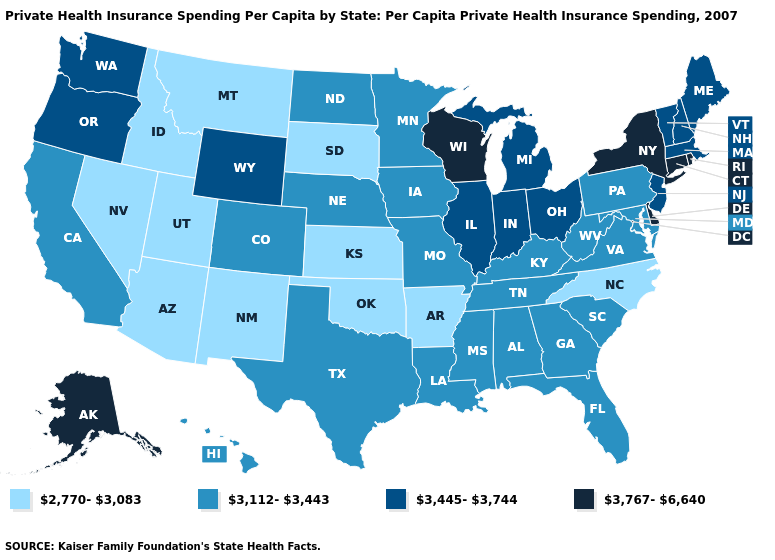Does the first symbol in the legend represent the smallest category?
Answer briefly. Yes. What is the highest value in the South ?
Give a very brief answer. 3,767-6,640. Which states hav the highest value in the Northeast?
Concise answer only. Connecticut, New York, Rhode Island. Does the map have missing data?
Answer briefly. No. Name the states that have a value in the range 3,445-3,744?
Write a very short answer. Illinois, Indiana, Maine, Massachusetts, Michigan, New Hampshire, New Jersey, Ohio, Oregon, Vermont, Washington, Wyoming. Is the legend a continuous bar?
Answer briefly. No. Name the states that have a value in the range 3,445-3,744?
Concise answer only. Illinois, Indiana, Maine, Massachusetts, Michigan, New Hampshire, New Jersey, Ohio, Oregon, Vermont, Washington, Wyoming. Name the states that have a value in the range 3,112-3,443?
Quick response, please. Alabama, California, Colorado, Florida, Georgia, Hawaii, Iowa, Kentucky, Louisiana, Maryland, Minnesota, Mississippi, Missouri, Nebraska, North Dakota, Pennsylvania, South Carolina, Tennessee, Texas, Virginia, West Virginia. Does Maryland have the highest value in the USA?
Write a very short answer. No. What is the value of Montana?
Write a very short answer. 2,770-3,083. Which states have the lowest value in the MidWest?
Concise answer only. Kansas, South Dakota. Among the states that border Maine , which have the lowest value?
Answer briefly. New Hampshire. Does California have the lowest value in the West?
Short answer required. No. Which states have the lowest value in the USA?
Short answer required. Arizona, Arkansas, Idaho, Kansas, Montana, Nevada, New Mexico, North Carolina, Oklahoma, South Dakota, Utah. Does Wisconsin have the highest value in the USA?
Answer briefly. Yes. 